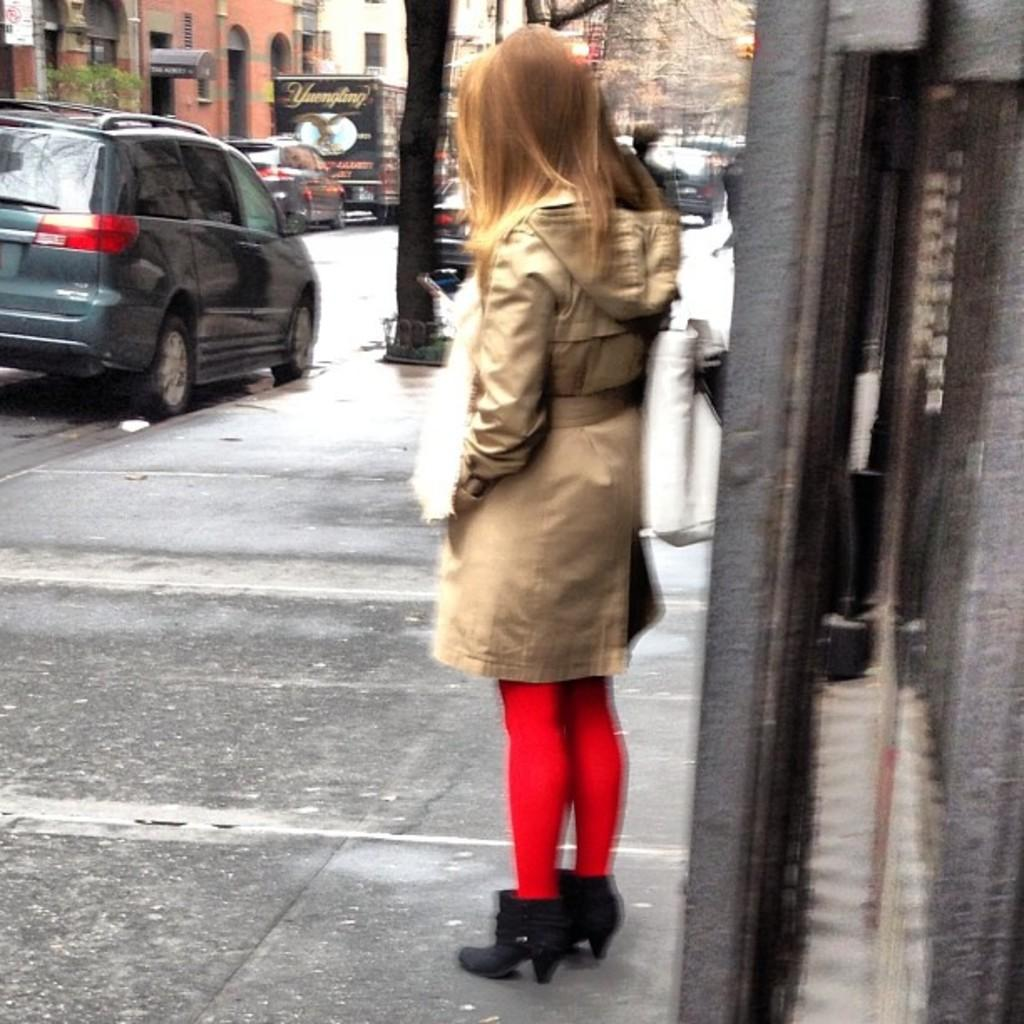Who is the main subject in the image? There is a girl in the image. What is the girl doing in the image? The girl is standing in front of a building. What else can be seen in the image besides the girl? There are cars visible in the image. What type of structures are present on either side of the girl? There are buildings on either side of the girl. What type of steel is the girl using to take a bath in the image? There is no steel or bath present in the image; it features a girl standing in front of a building with cars and other buildings nearby. 